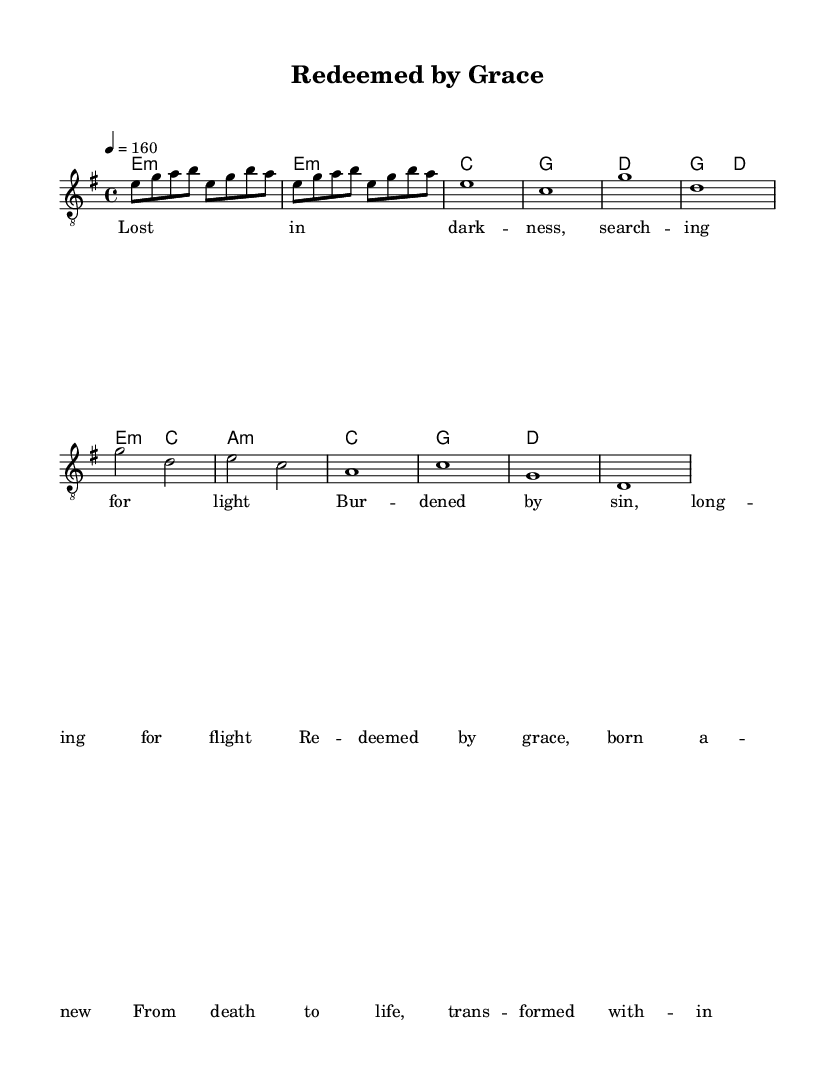What is the key signature of this music? The key signature is found at the beginning of the piece. It shows two sharps (F# and C#), indicating that it is in E minor.
Answer: E minor What is the time signature of this music? The time signature appears next to the key signature at the beginning of the score. It is indicated as 4/4, meaning there are four beats in each measure.
Answer: 4/4 What is the tempo marking for the piece? The tempo marking is given at the start of the music, specifying the speed of the performance. It is indicated as four equals 160 beats per minute.
Answer: 160 How many verses does this song have? By analyzing the structure of the lyrics, we can see that there is one verse present before the chorus, suggesting there is only one verse.
Answer: 1 What primary theme does the chorus express? The chorus contains lyrics that reflect a powerful message of transformation and renewal, highlighting the theme of redemption. The words "Redeemed by grace, born anew" directly point to this central idea.
Answer: Redemption What is the musical style of this piece? The characteristics of the composition and lyrical themes suggest that this piece falls under the category of Christian metal, focusing on intense instrumentation and faith-based themes.
Answer: Christian metal What type of chord is used in the chorus? The chord symbols above the chorus indicate that the music employs minor chords, particularly e minor, along with major ones like G and D, which are common in metal.
Answer: Minor and major chords 